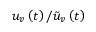Convert formula to latex. <formula><loc_0><loc_0><loc_500><loc_500>u _ { v } \left ( t \right ) / \tilde { u } _ { v } \left ( t \right )</formula> 